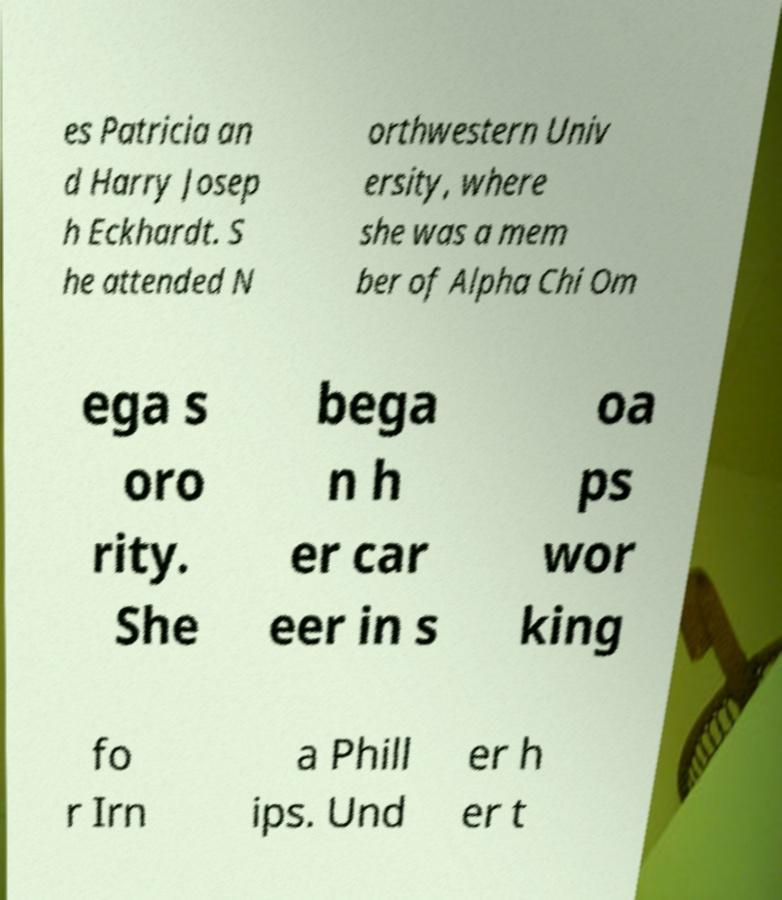Could you extract and type out the text from this image? es Patricia an d Harry Josep h Eckhardt. S he attended N orthwestern Univ ersity, where she was a mem ber of Alpha Chi Om ega s oro rity. She bega n h er car eer in s oa ps wor king fo r Irn a Phill ips. Und er h er t 